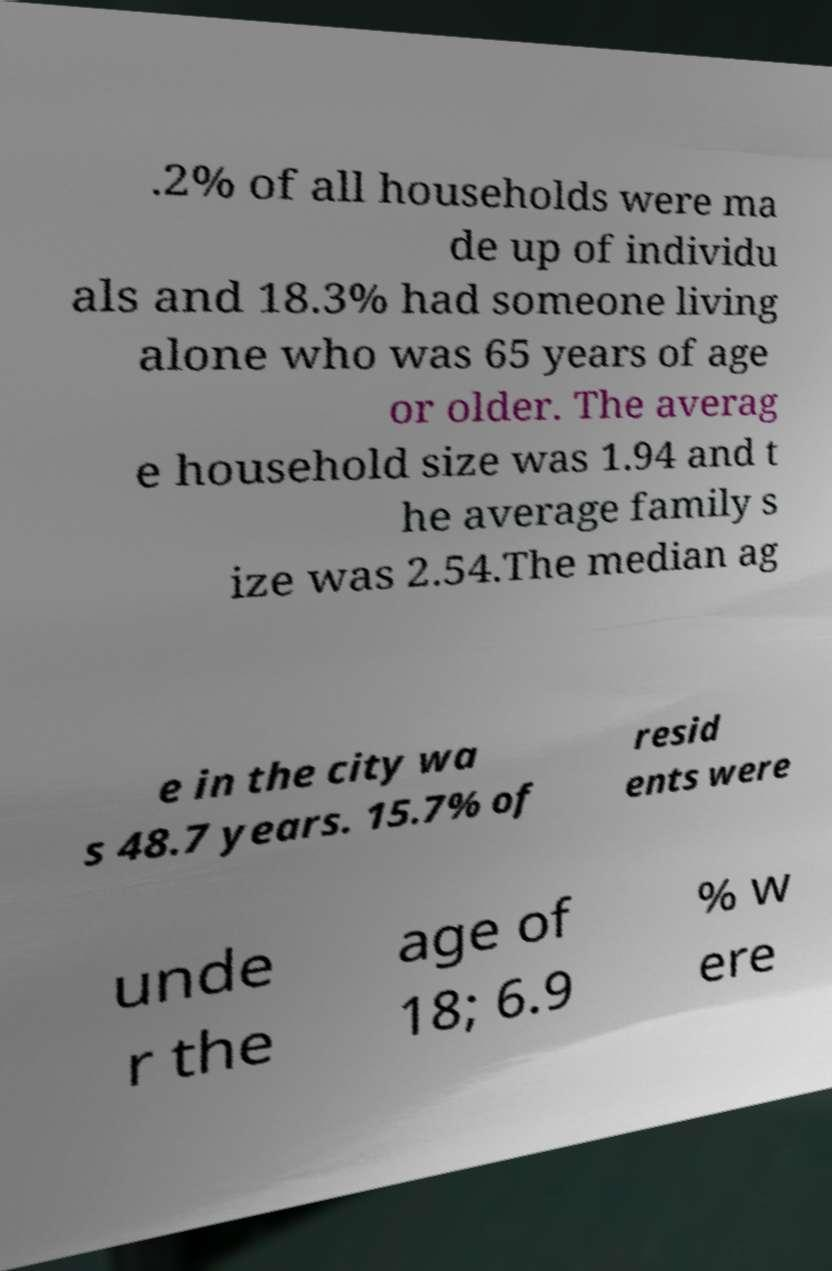Please identify and transcribe the text found in this image. .2% of all households were ma de up of individu als and 18.3% had someone living alone who was 65 years of age or older. The averag e household size was 1.94 and t he average family s ize was 2.54.The median ag e in the city wa s 48.7 years. 15.7% of resid ents were unde r the age of 18; 6.9 % w ere 